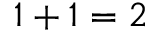Convert formula to latex. <formula><loc_0><loc_0><loc_500><loc_500>1 + 1 = 2</formula> 